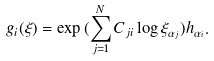<formula> <loc_0><loc_0><loc_500><loc_500>g _ { i } ( \xi ) = \exp { ( \sum _ { j = 1 } ^ { N } C _ { j i } \log { \xi _ { \alpha _ { j } } } ) h _ { \alpha _ { i } } } .</formula> 